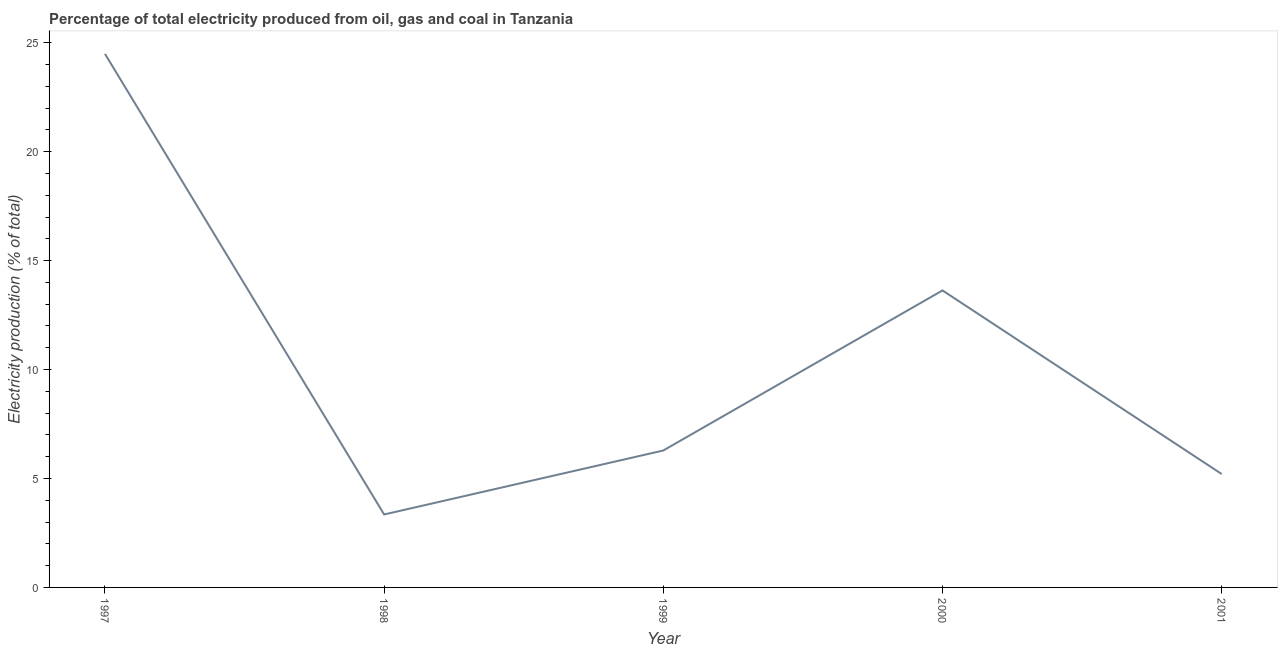What is the electricity production in 1997?
Give a very brief answer. 24.49. Across all years, what is the maximum electricity production?
Make the answer very short. 24.49. Across all years, what is the minimum electricity production?
Your answer should be very brief. 3.35. In which year was the electricity production maximum?
Ensure brevity in your answer.  1997. What is the sum of the electricity production?
Keep it short and to the point. 52.97. What is the difference between the electricity production in 1998 and 2000?
Your answer should be very brief. -10.28. What is the average electricity production per year?
Offer a very short reply. 10.59. What is the median electricity production?
Make the answer very short. 6.29. In how many years, is the electricity production greater than 6 %?
Your response must be concise. 3. What is the ratio of the electricity production in 1998 to that in 2000?
Your response must be concise. 0.25. Is the electricity production in 1998 less than that in 2000?
Offer a very short reply. Yes. What is the difference between the highest and the second highest electricity production?
Offer a terse response. 10.86. Is the sum of the electricity production in 1999 and 2001 greater than the maximum electricity production across all years?
Provide a succinct answer. No. What is the difference between the highest and the lowest electricity production?
Ensure brevity in your answer.  21.14. How many years are there in the graph?
Make the answer very short. 5. What is the difference between two consecutive major ticks on the Y-axis?
Provide a succinct answer. 5. Are the values on the major ticks of Y-axis written in scientific E-notation?
Offer a very short reply. No. What is the title of the graph?
Your response must be concise. Percentage of total electricity produced from oil, gas and coal in Tanzania. What is the label or title of the Y-axis?
Offer a very short reply. Electricity production (% of total). What is the Electricity production (% of total) in 1997?
Ensure brevity in your answer.  24.49. What is the Electricity production (% of total) in 1998?
Your answer should be compact. 3.35. What is the Electricity production (% of total) in 1999?
Provide a short and direct response. 6.29. What is the Electricity production (% of total) of 2000?
Provide a short and direct response. 13.63. What is the Electricity production (% of total) in 2001?
Your response must be concise. 5.21. What is the difference between the Electricity production (% of total) in 1997 and 1998?
Offer a very short reply. 21.14. What is the difference between the Electricity production (% of total) in 1997 and 1999?
Your answer should be compact. 18.21. What is the difference between the Electricity production (% of total) in 1997 and 2000?
Offer a terse response. 10.86. What is the difference between the Electricity production (% of total) in 1997 and 2001?
Provide a succinct answer. 19.29. What is the difference between the Electricity production (% of total) in 1998 and 1999?
Your answer should be very brief. -2.94. What is the difference between the Electricity production (% of total) in 1998 and 2000?
Ensure brevity in your answer.  -10.28. What is the difference between the Electricity production (% of total) in 1998 and 2001?
Your response must be concise. -1.86. What is the difference between the Electricity production (% of total) in 1999 and 2000?
Give a very brief answer. -7.35. What is the difference between the Electricity production (% of total) in 1999 and 2001?
Offer a terse response. 1.08. What is the difference between the Electricity production (% of total) in 2000 and 2001?
Make the answer very short. 8.43. What is the ratio of the Electricity production (% of total) in 1997 to that in 1998?
Your response must be concise. 7.31. What is the ratio of the Electricity production (% of total) in 1997 to that in 1999?
Give a very brief answer. 3.9. What is the ratio of the Electricity production (% of total) in 1997 to that in 2000?
Your answer should be very brief. 1.8. What is the ratio of the Electricity production (% of total) in 1997 to that in 2001?
Make the answer very short. 4.7. What is the ratio of the Electricity production (% of total) in 1998 to that in 1999?
Your answer should be compact. 0.53. What is the ratio of the Electricity production (% of total) in 1998 to that in 2000?
Provide a short and direct response. 0.25. What is the ratio of the Electricity production (% of total) in 1998 to that in 2001?
Provide a short and direct response. 0.64. What is the ratio of the Electricity production (% of total) in 1999 to that in 2000?
Offer a very short reply. 0.46. What is the ratio of the Electricity production (% of total) in 1999 to that in 2001?
Provide a succinct answer. 1.21. What is the ratio of the Electricity production (% of total) in 2000 to that in 2001?
Give a very brief answer. 2.62. 